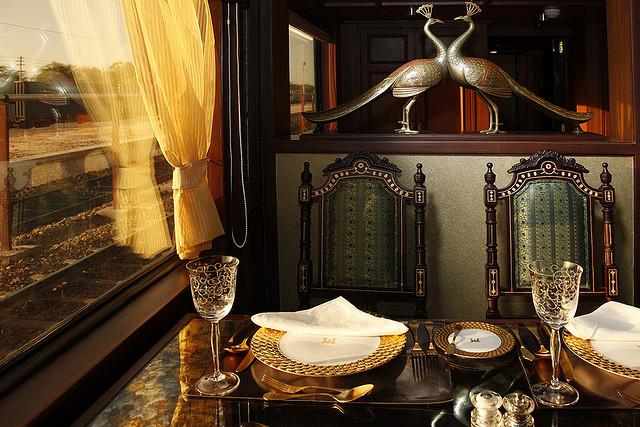How many chairs in the picture?
Be succinct. 2. What kind of birds do the statues above the chairs represent?
Write a very short answer. Peacocks. How many glasses are in the picture?
Concise answer only. 2. 